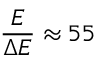<formula> <loc_0><loc_0><loc_500><loc_500>\frac { E } { E } 5 5</formula> 